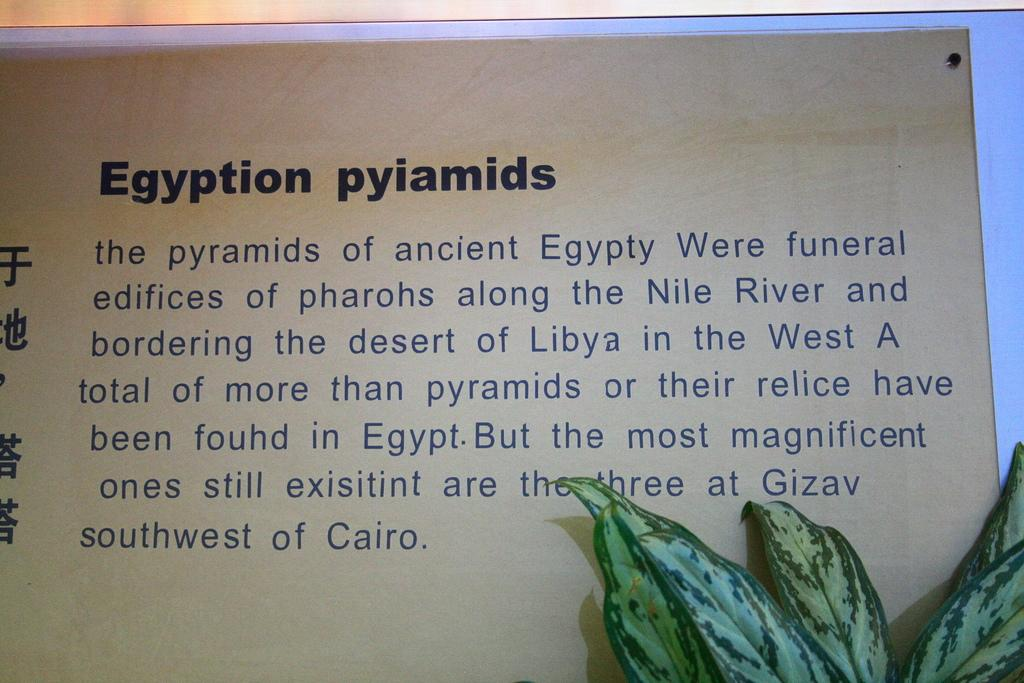<image>
Describe the image concisely. A page is titled Egyptian pyiamids and has a plant in the bottom corner. 